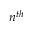<formula> <loc_0><loc_0><loc_500><loc_500>n ^ { t h }</formula> 